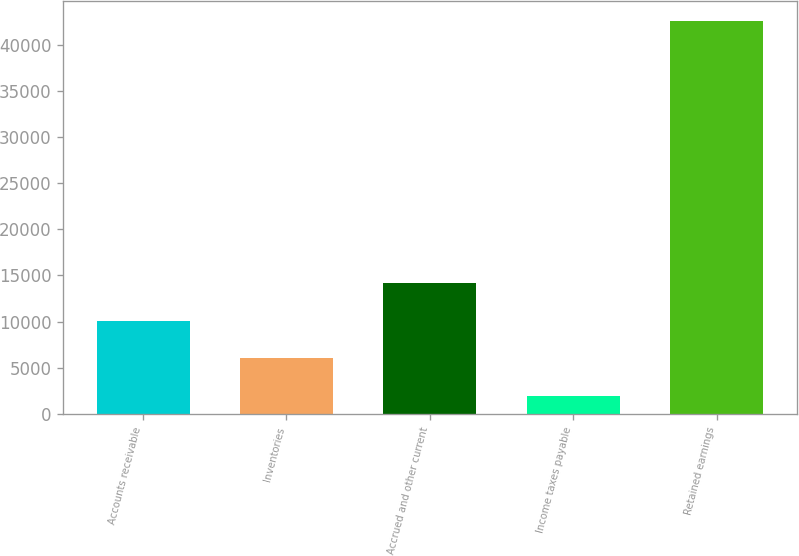Convert chart. <chart><loc_0><loc_0><loc_500><loc_500><bar_chart><fcel>Accounts receivable<fcel>Inventories<fcel>Accrued and other current<fcel>Income taxes payable<fcel>Retained earnings<nl><fcel>10092.6<fcel>6031.8<fcel>14153.4<fcel>1971<fcel>42579<nl></chart> 